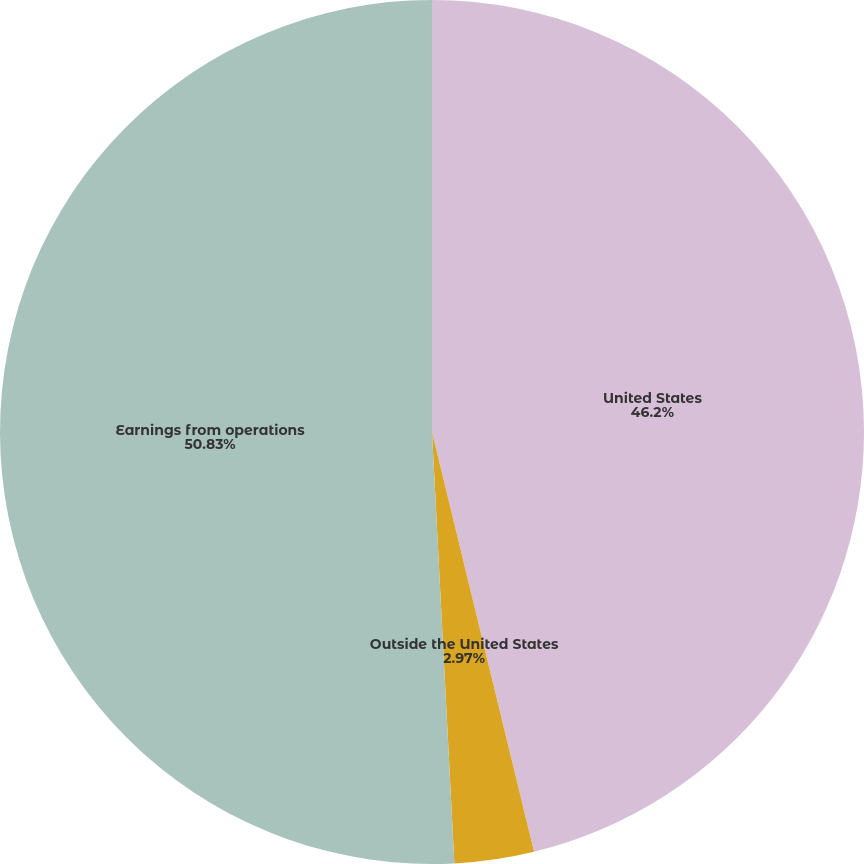Convert chart. <chart><loc_0><loc_0><loc_500><loc_500><pie_chart><fcel>United States<fcel>Outside the United States<fcel>Earnings from operations<nl><fcel>46.2%<fcel>2.97%<fcel>50.82%<nl></chart> 